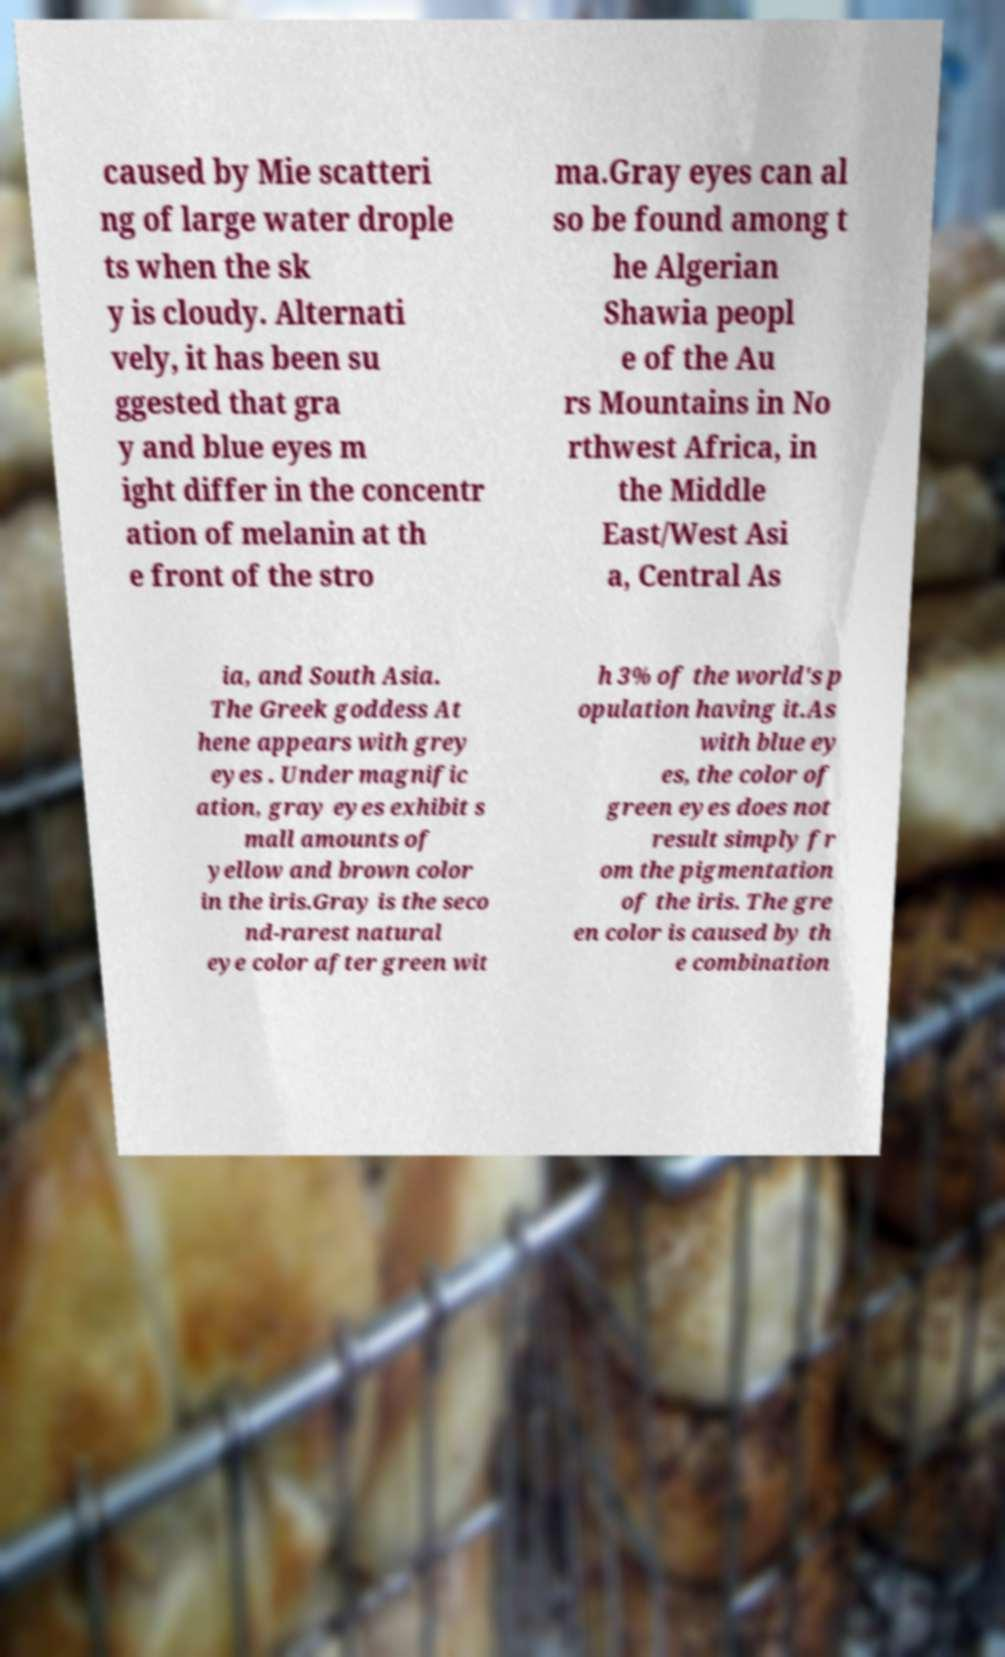Please read and relay the text visible in this image. What does it say? caused by Mie scatteri ng of large water drople ts when the sk y is cloudy. Alternati vely, it has been su ggested that gra y and blue eyes m ight differ in the concentr ation of melanin at th e front of the stro ma.Gray eyes can al so be found among t he Algerian Shawia peopl e of the Au rs Mountains in No rthwest Africa, in the Middle East/West Asi a, Central As ia, and South Asia. The Greek goddess At hene appears with grey eyes . Under magnific ation, gray eyes exhibit s mall amounts of yellow and brown color in the iris.Gray is the seco nd-rarest natural eye color after green wit h 3% of the world's p opulation having it.As with blue ey es, the color of green eyes does not result simply fr om the pigmentation of the iris. The gre en color is caused by th e combination 